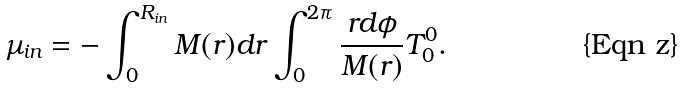Convert formula to latex. <formula><loc_0><loc_0><loc_500><loc_500>\mu _ { i n } = - \int _ { 0 } ^ { R _ { i n } } M ( r ) d r \int _ { 0 } ^ { 2 \pi } \frac { r d \phi } { M ( r ) } T ^ { 0 } _ { 0 } .</formula> 